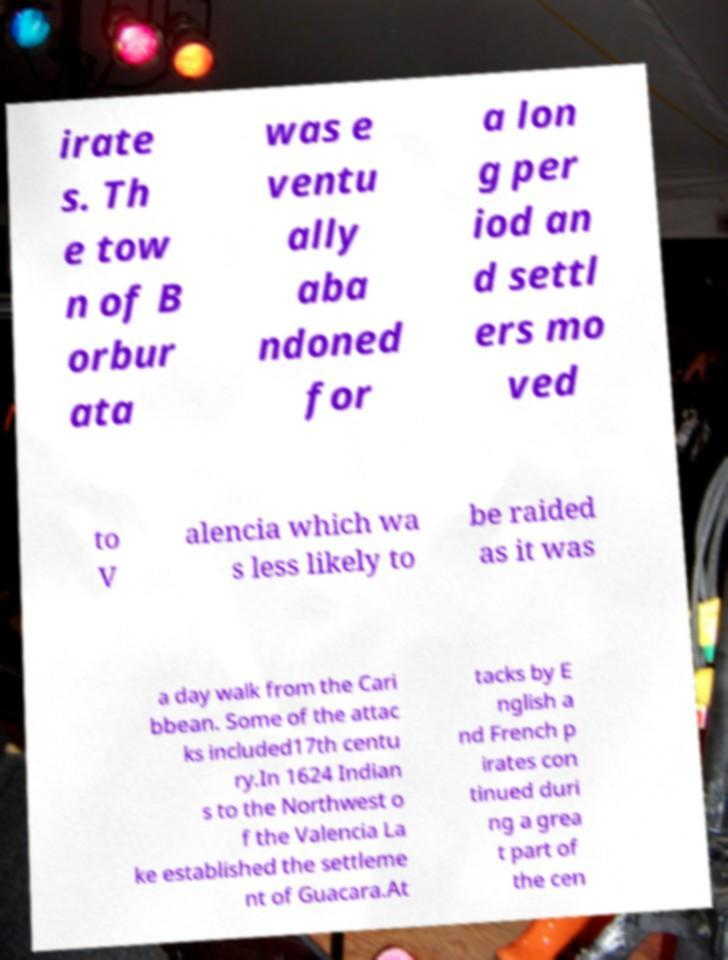I need the written content from this picture converted into text. Can you do that? irate s. Th e tow n of B orbur ata was e ventu ally aba ndoned for a lon g per iod an d settl ers mo ved to V alencia which wa s less likely to be raided as it was a day walk from the Cari bbean. Some of the attac ks included17th centu ry.In 1624 Indian s to the Northwest o f the Valencia La ke established the settleme nt of Guacara.At tacks by E nglish a nd French p irates con tinued duri ng a grea t part of the cen 